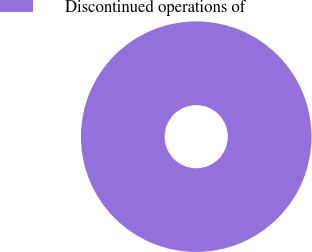Convert chart to OTSL. <chart><loc_0><loc_0><loc_500><loc_500><pie_chart><fcel>Discontinued operations of<nl><fcel>100.0%<nl></chart> 